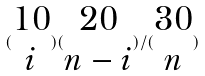Convert formula to latex. <formula><loc_0><loc_0><loc_500><loc_500>( \begin{matrix} 1 0 \\ i \end{matrix} ) ( \begin{matrix} 2 0 \\ n - i \end{matrix} ) / ( \begin{matrix} 3 0 \\ n \end{matrix} )</formula> 